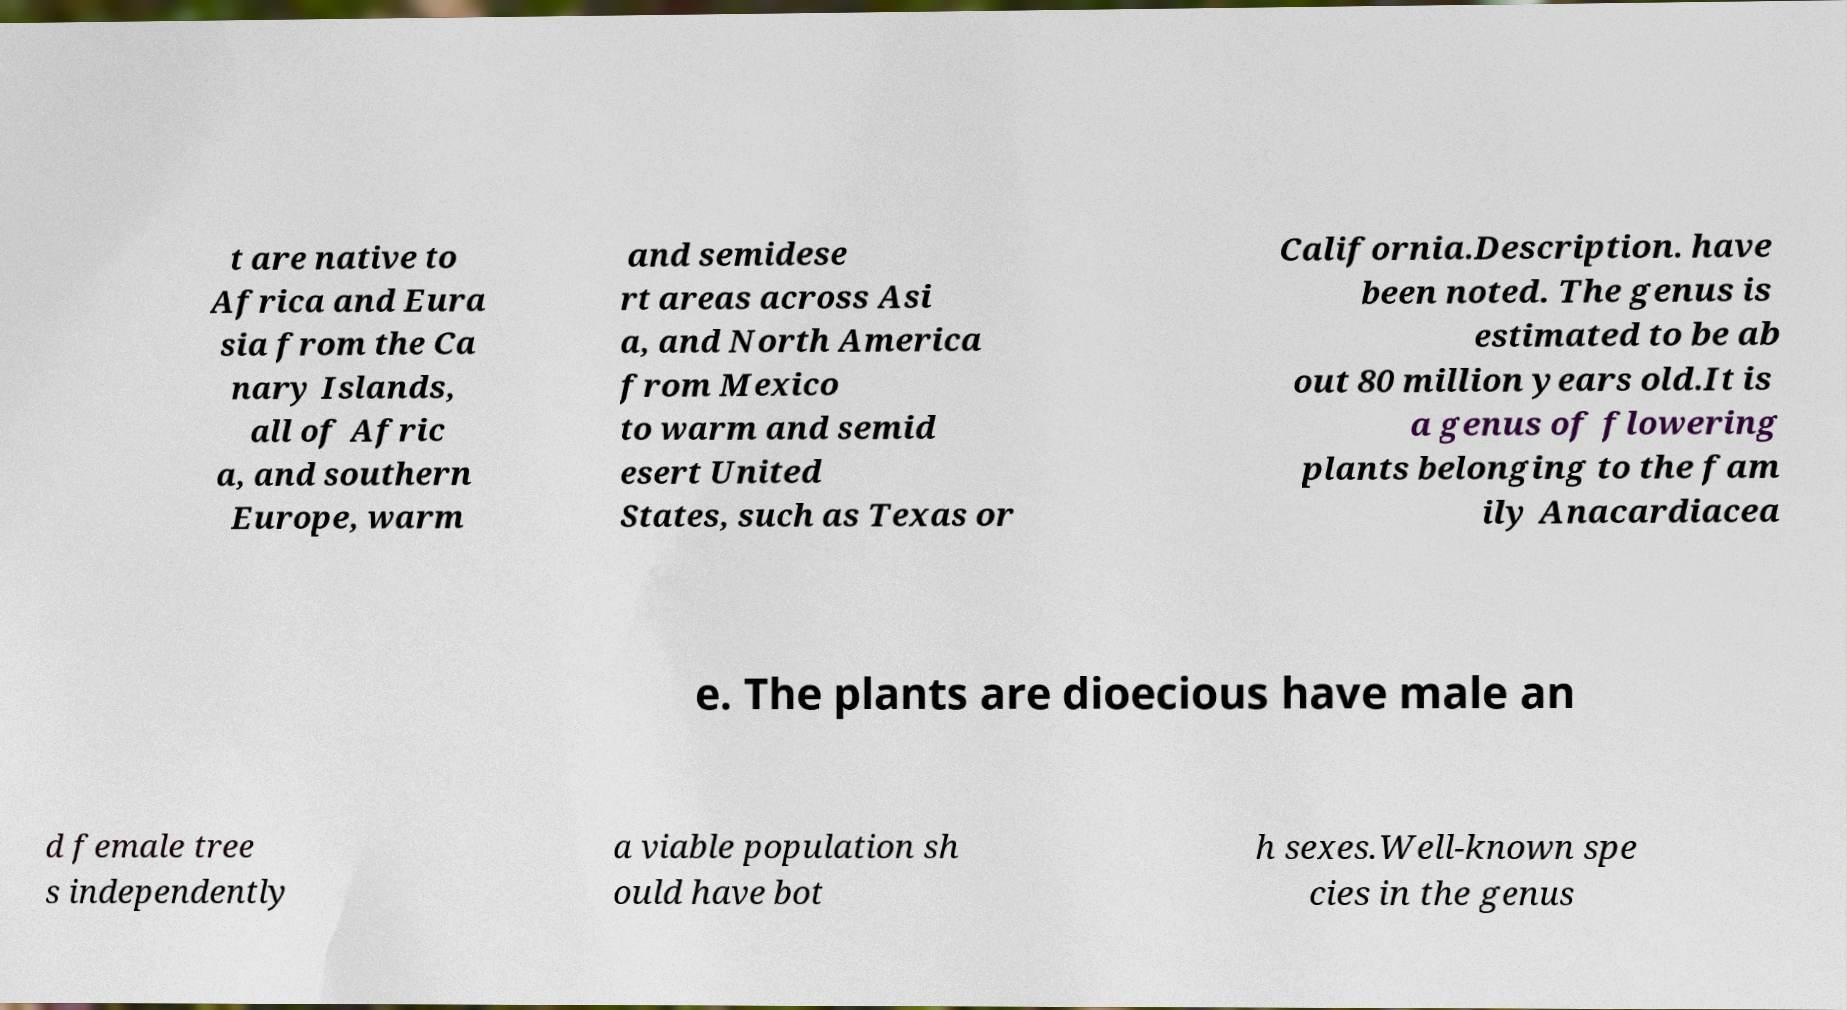Please identify and transcribe the text found in this image. t are native to Africa and Eura sia from the Ca nary Islands, all of Afric a, and southern Europe, warm and semidese rt areas across Asi a, and North America from Mexico to warm and semid esert United States, such as Texas or California.Description. have been noted. The genus is estimated to be ab out 80 million years old.It is a genus of flowering plants belonging to the fam ily Anacardiacea e. The plants are dioecious have male an d female tree s independently a viable population sh ould have bot h sexes.Well-known spe cies in the genus 